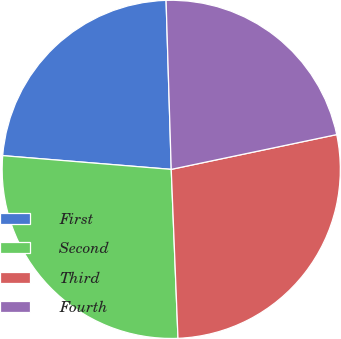Convert chart to OTSL. <chart><loc_0><loc_0><loc_500><loc_500><pie_chart><fcel>First<fcel>Second<fcel>Third<fcel>Fourth<nl><fcel>23.22%<fcel>26.93%<fcel>27.66%<fcel>22.19%<nl></chart> 